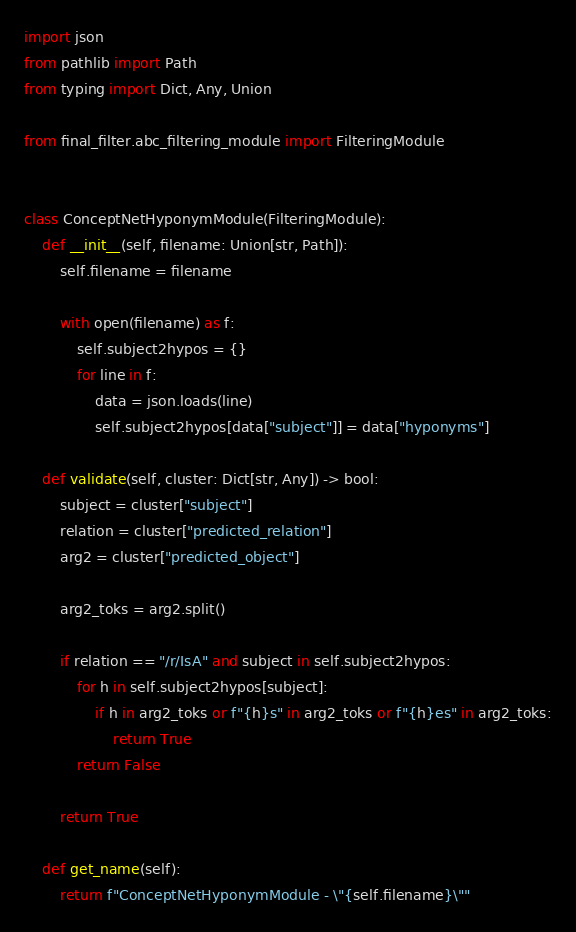<code> <loc_0><loc_0><loc_500><loc_500><_Python_>import json
from pathlib import Path
from typing import Dict, Any, Union

from final_filter.abc_filtering_module import FilteringModule


class ConceptNetHyponymModule(FilteringModule):
    def __init__(self, filename: Union[str, Path]):
        self.filename = filename

        with open(filename) as f:
            self.subject2hypos = {}
            for line in f:
                data = json.loads(line)
                self.subject2hypos[data["subject"]] = data["hyponyms"]

    def validate(self, cluster: Dict[str, Any]) -> bool:
        subject = cluster["subject"]
        relation = cluster["predicted_relation"]
        arg2 = cluster["predicted_object"]

        arg2_toks = arg2.split()

        if relation == "/r/IsA" and subject in self.subject2hypos:
            for h in self.subject2hypos[subject]:
                if h in arg2_toks or f"{h}s" in arg2_toks or f"{h}es" in arg2_toks:
                    return True
            return False

        return True

    def get_name(self):
        return f"ConceptNetHyponymModule - \"{self.filename}\""
</code> 